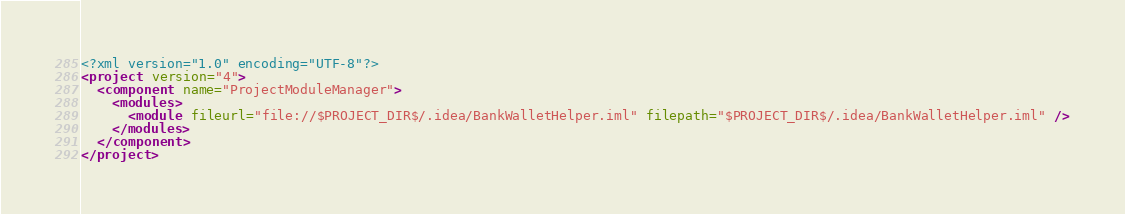Convert code to text. <code><loc_0><loc_0><loc_500><loc_500><_XML_><?xml version="1.0" encoding="UTF-8"?>
<project version="4">
  <component name="ProjectModuleManager">
    <modules>
      <module fileurl="file://$PROJECT_DIR$/.idea/BankWalletHelper.iml" filepath="$PROJECT_DIR$/.idea/BankWalletHelper.iml" />
    </modules>
  </component>
</project></code> 